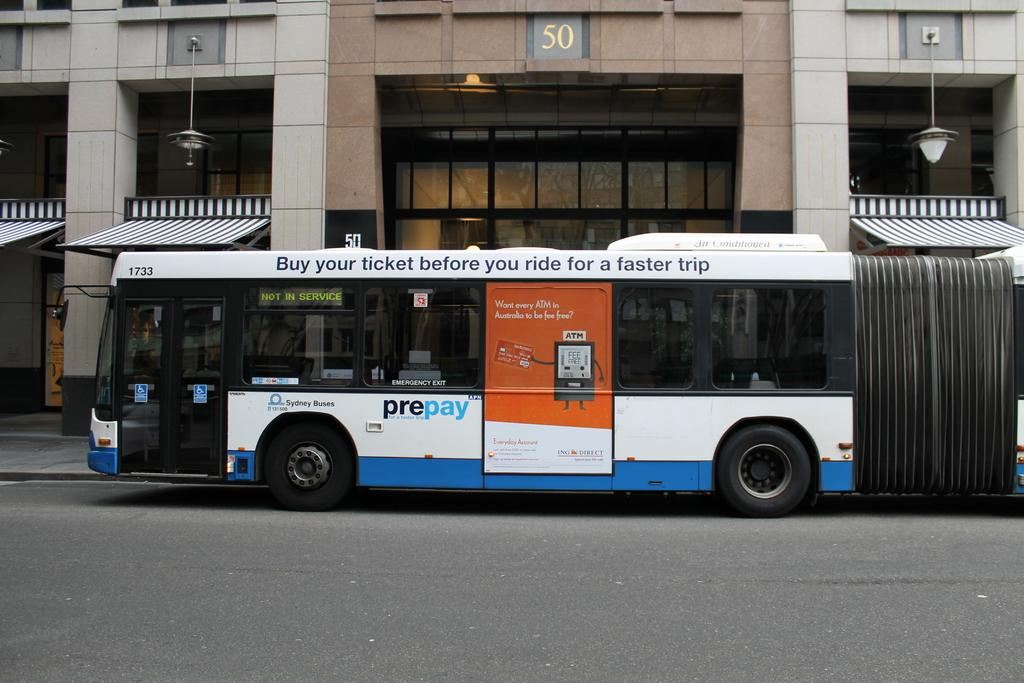<image>
Describe the image concisely. A sign on a bus instructs people to buy tickets before they ride. 